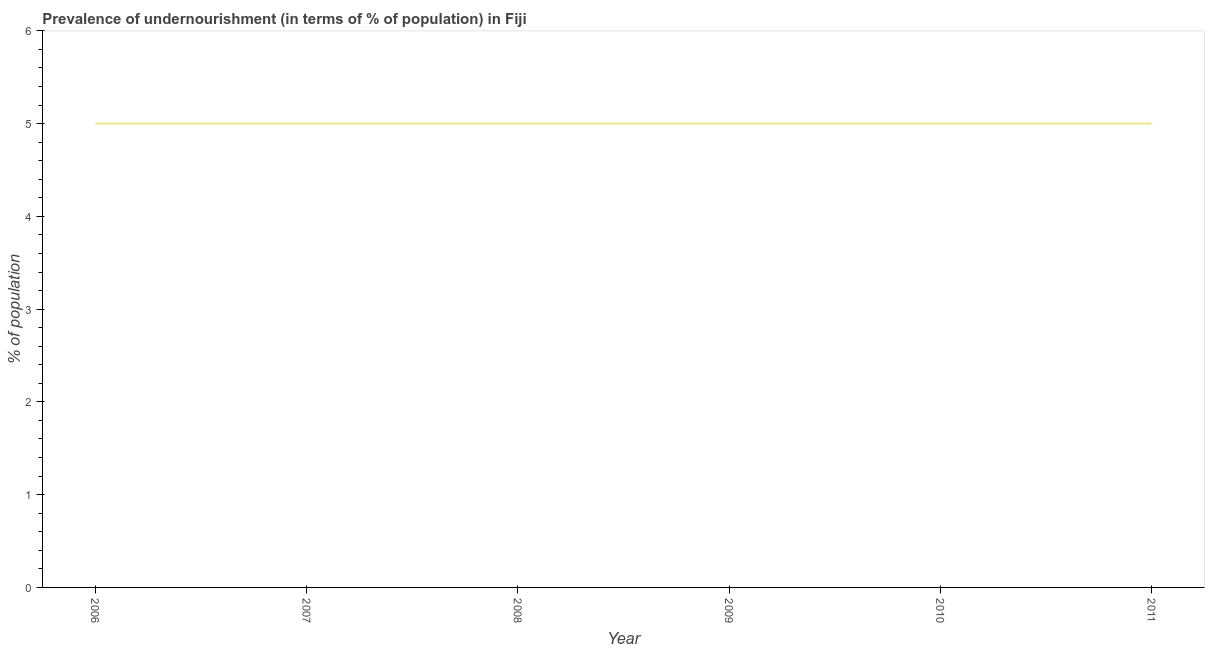What is the difference between the percentage of undernourished population in 2007 and 2010?
Offer a very short reply. 0. What is the ratio of the percentage of undernourished population in 2007 to that in 2010?
Make the answer very short. 1. What is the difference between the highest and the second highest percentage of undernourished population?
Your response must be concise. 0. What is the difference between the highest and the lowest percentage of undernourished population?
Ensure brevity in your answer.  0. In how many years, is the percentage of undernourished population greater than the average percentage of undernourished population taken over all years?
Provide a short and direct response. 0. How many lines are there?
Give a very brief answer. 1. What is the difference between two consecutive major ticks on the Y-axis?
Ensure brevity in your answer.  1. Are the values on the major ticks of Y-axis written in scientific E-notation?
Provide a short and direct response. No. Does the graph contain any zero values?
Offer a very short reply. No. What is the title of the graph?
Your answer should be compact. Prevalence of undernourishment (in terms of % of population) in Fiji. What is the label or title of the Y-axis?
Ensure brevity in your answer.  % of population. What is the % of population in 2006?
Provide a succinct answer. 5. What is the % of population in 2010?
Provide a short and direct response. 5. What is the % of population in 2011?
Your answer should be compact. 5. What is the difference between the % of population in 2006 and 2007?
Provide a succinct answer. 0. What is the difference between the % of population in 2007 and 2008?
Your response must be concise. 0. What is the difference between the % of population in 2007 and 2009?
Offer a terse response. 0. What is the difference between the % of population in 2007 and 2010?
Offer a very short reply. 0. What is the difference between the % of population in 2007 and 2011?
Offer a very short reply. 0. What is the difference between the % of population in 2008 and 2009?
Offer a very short reply. 0. What is the difference between the % of population in 2008 and 2011?
Make the answer very short. 0. What is the difference between the % of population in 2009 and 2011?
Make the answer very short. 0. What is the ratio of the % of population in 2006 to that in 2009?
Offer a very short reply. 1. What is the ratio of the % of population in 2006 to that in 2011?
Give a very brief answer. 1. What is the ratio of the % of population in 2008 to that in 2010?
Ensure brevity in your answer.  1. What is the ratio of the % of population in 2009 to that in 2010?
Provide a short and direct response. 1. What is the ratio of the % of population in 2009 to that in 2011?
Offer a terse response. 1. 